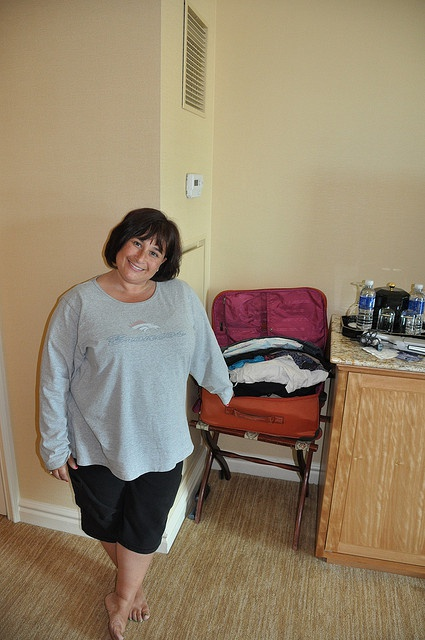Describe the objects in this image and their specific colors. I can see people in gray, darkgray, and black tones, suitcase in gray, maroon, black, darkgray, and brown tones, chair in gray, maroon, black, and brown tones, bottle in gray, darkgray, black, and navy tones, and bottle in gray, navy, darkgray, and darkblue tones in this image. 